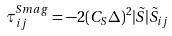Convert formula to latex. <formula><loc_0><loc_0><loc_500><loc_500>\tau ^ { S m a g } _ { i j } = - 2 ( C _ { S } \Delta ) ^ { 2 } | \tilde { S } | \tilde { S } _ { i j }</formula> 